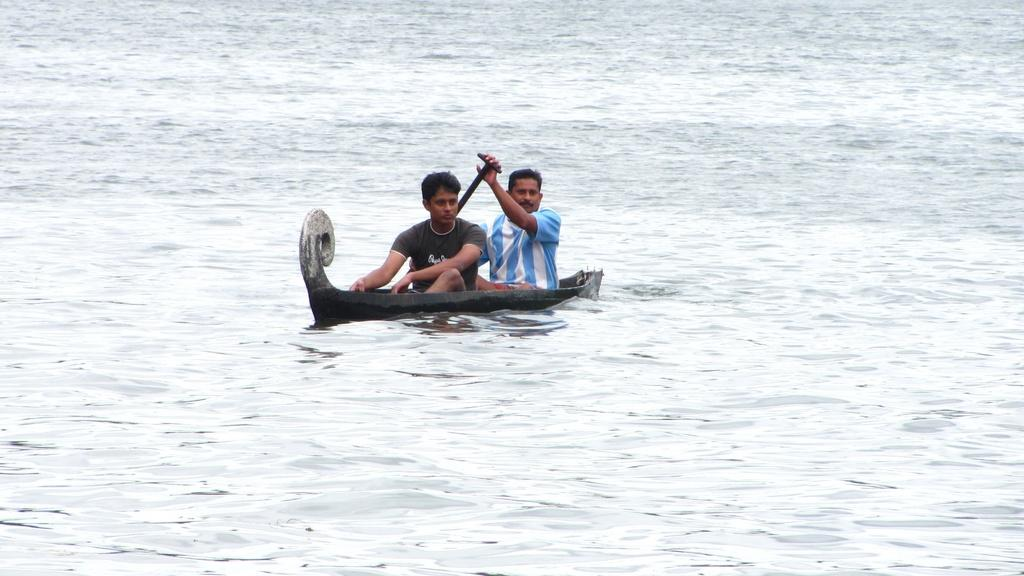How many people are in the image? There are two men in the image. What are the men doing in the image? The men are sitting on a boat. What is one of the men holding? One of the men is holding a paddle. What can be seen in the background of the image? There is water visible in the image. What type of adjustment is being made to the team in the image? There is no team present in the image, and therefore no adjustments are being made. Is it raining in the image? The provided facts do not mention rain, so we cannot determine if it is raining in the image. 